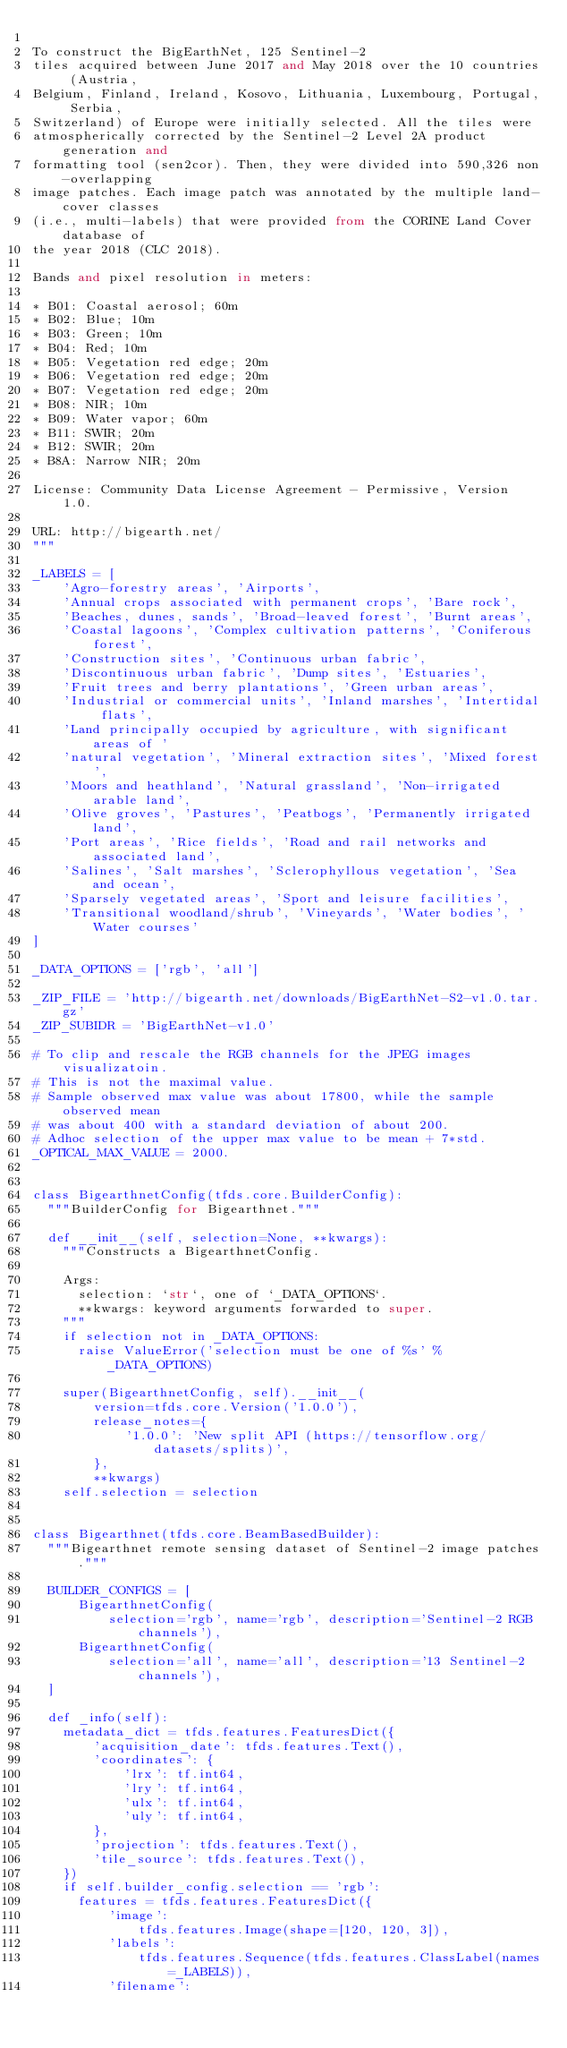<code> <loc_0><loc_0><loc_500><loc_500><_Python_>
To construct the BigEarthNet, 125 Sentinel-2
tiles acquired between June 2017 and May 2018 over the 10 countries (Austria,
Belgium, Finland, Ireland, Kosovo, Lithuania, Luxembourg, Portugal, Serbia,
Switzerland) of Europe were initially selected. All the tiles were
atmospherically corrected by the Sentinel-2 Level 2A product generation and
formatting tool (sen2cor). Then, they were divided into 590,326 non-overlapping
image patches. Each image patch was annotated by the multiple land-cover classes
(i.e., multi-labels) that were provided from the CORINE Land Cover database of
the year 2018 (CLC 2018).

Bands and pixel resolution in meters:

* B01: Coastal aerosol; 60m
* B02: Blue; 10m
* B03: Green; 10m
* B04: Red; 10m
* B05: Vegetation red edge; 20m
* B06: Vegetation red edge; 20m
* B07: Vegetation red edge; 20m
* B08: NIR; 10m
* B09: Water vapor; 60m
* B11: SWIR; 20m
* B12: SWIR; 20m
* B8A: Narrow NIR; 20m

License: Community Data License Agreement - Permissive, Version 1.0.

URL: http://bigearth.net/
"""

_LABELS = [
    'Agro-forestry areas', 'Airports',
    'Annual crops associated with permanent crops', 'Bare rock',
    'Beaches, dunes, sands', 'Broad-leaved forest', 'Burnt areas',
    'Coastal lagoons', 'Complex cultivation patterns', 'Coniferous forest',
    'Construction sites', 'Continuous urban fabric',
    'Discontinuous urban fabric', 'Dump sites', 'Estuaries',
    'Fruit trees and berry plantations', 'Green urban areas',
    'Industrial or commercial units', 'Inland marshes', 'Intertidal flats',
    'Land principally occupied by agriculture, with significant areas of '
    'natural vegetation', 'Mineral extraction sites', 'Mixed forest',
    'Moors and heathland', 'Natural grassland', 'Non-irrigated arable land',
    'Olive groves', 'Pastures', 'Peatbogs', 'Permanently irrigated land',
    'Port areas', 'Rice fields', 'Road and rail networks and associated land',
    'Salines', 'Salt marshes', 'Sclerophyllous vegetation', 'Sea and ocean',
    'Sparsely vegetated areas', 'Sport and leisure facilities',
    'Transitional woodland/shrub', 'Vineyards', 'Water bodies', 'Water courses'
]

_DATA_OPTIONS = ['rgb', 'all']

_ZIP_FILE = 'http://bigearth.net/downloads/BigEarthNet-S2-v1.0.tar.gz'
_ZIP_SUBIDR = 'BigEarthNet-v1.0'

# To clip and rescale the RGB channels for the JPEG images visualizatoin.
# This is not the maximal value.
# Sample observed max value was about 17800, while the sample observed mean
# was about 400 with a standard deviation of about 200.
# Adhoc selection of the upper max value to be mean + 7*std.
_OPTICAL_MAX_VALUE = 2000.


class BigearthnetConfig(tfds.core.BuilderConfig):
  """BuilderConfig for Bigearthnet."""

  def __init__(self, selection=None, **kwargs):
    """Constructs a BigearthnetConfig.

    Args:
      selection: `str`, one of `_DATA_OPTIONS`.
      **kwargs: keyword arguments forwarded to super.
    """
    if selection not in _DATA_OPTIONS:
      raise ValueError('selection must be one of %s' % _DATA_OPTIONS)

    super(BigearthnetConfig, self).__init__(
        version=tfds.core.Version('1.0.0'),
        release_notes={
            '1.0.0': 'New split API (https://tensorflow.org/datasets/splits)',
        },
        **kwargs)
    self.selection = selection


class Bigearthnet(tfds.core.BeamBasedBuilder):
  """Bigearthnet remote sensing dataset of Sentinel-2 image patches."""

  BUILDER_CONFIGS = [
      BigearthnetConfig(
          selection='rgb', name='rgb', description='Sentinel-2 RGB channels'),
      BigearthnetConfig(
          selection='all', name='all', description='13 Sentinel-2 channels'),
  ]

  def _info(self):
    metadata_dict = tfds.features.FeaturesDict({
        'acquisition_date': tfds.features.Text(),
        'coordinates': {
            'lrx': tf.int64,
            'lry': tf.int64,
            'ulx': tf.int64,
            'uly': tf.int64,
        },
        'projection': tfds.features.Text(),
        'tile_source': tfds.features.Text(),
    })
    if self.builder_config.selection == 'rgb':
      features = tfds.features.FeaturesDict({
          'image':
              tfds.features.Image(shape=[120, 120, 3]),
          'labels':
              tfds.features.Sequence(tfds.features.ClassLabel(names=_LABELS)),
          'filename':</code> 